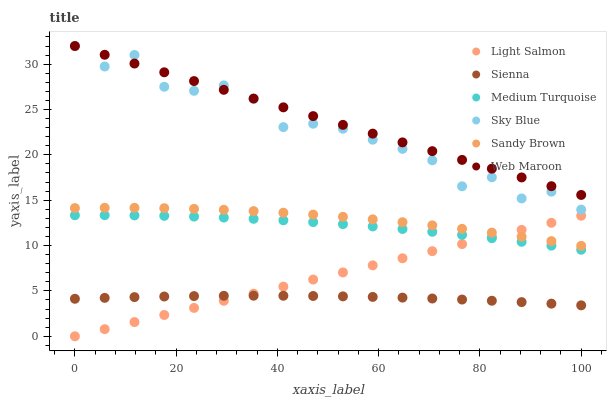Does Sienna have the minimum area under the curve?
Answer yes or no. Yes. Does Web Maroon have the maximum area under the curve?
Answer yes or no. Yes. Does Web Maroon have the minimum area under the curve?
Answer yes or no. No. Does Sienna have the maximum area under the curve?
Answer yes or no. No. Is Light Salmon the smoothest?
Answer yes or no. Yes. Is Sky Blue the roughest?
Answer yes or no. Yes. Is Web Maroon the smoothest?
Answer yes or no. No. Is Web Maroon the roughest?
Answer yes or no. No. Does Light Salmon have the lowest value?
Answer yes or no. Yes. Does Sienna have the lowest value?
Answer yes or no. No. Does Sky Blue have the highest value?
Answer yes or no. Yes. Does Sienna have the highest value?
Answer yes or no. No. Is Sienna less than Web Maroon?
Answer yes or no. Yes. Is Web Maroon greater than Medium Turquoise?
Answer yes or no. Yes. Does Medium Turquoise intersect Light Salmon?
Answer yes or no. Yes. Is Medium Turquoise less than Light Salmon?
Answer yes or no. No. Is Medium Turquoise greater than Light Salmon?
Answer yes or no. No. Does Sienna intersect Web Maroon?
Answer yes or no. No. 